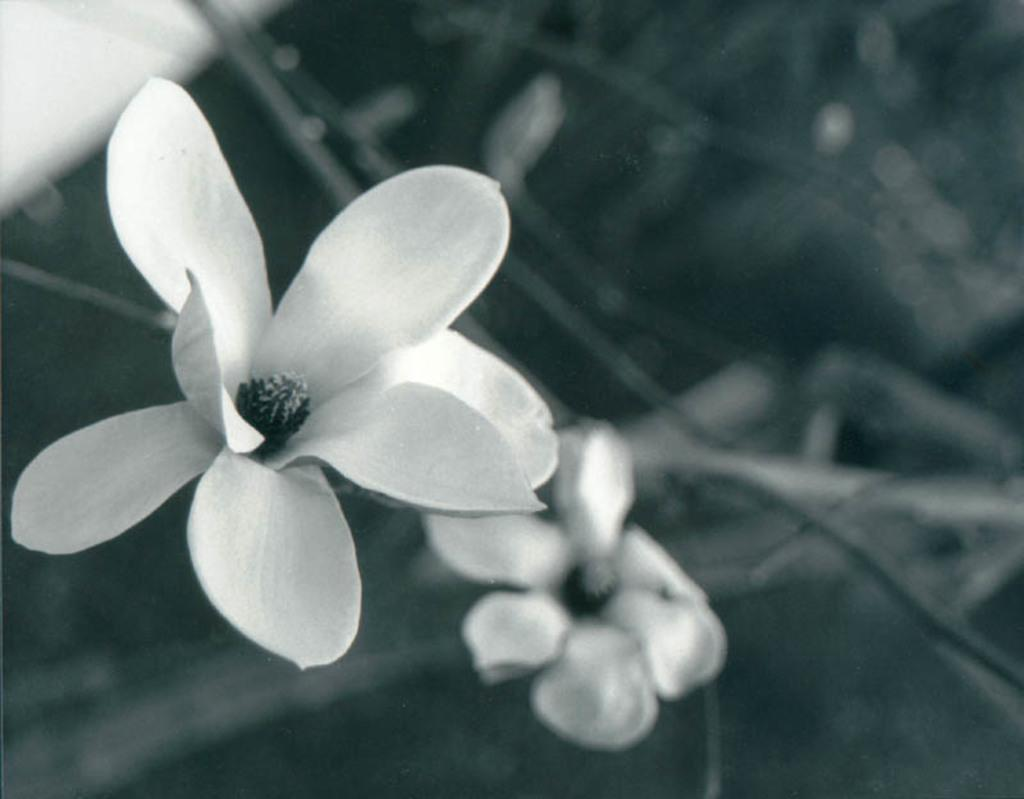What type of plants can be seen in the image? There are flowers in the image. What color are the flowers? The flowers are white in color. How many holes can be seen in the flowers in the image? There are no holes visible in the flowers in the image. 